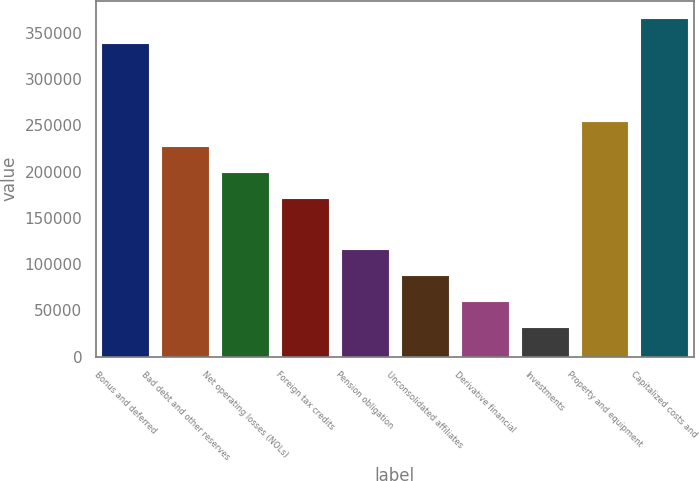<chart> <loc_0><loc_0><loc_500><loc_500><bar_chart><fcel>Bonus and deferred<fcel>Bad debt and other reserves<fcel>Net operating losses (NOLs)<fcel>Foreign tax credits<fcel>Pension obligation<fcel>Unconsolidated affiliates<fcel>Derivative financial<fcel>Investments<fcel>Property and equipment<fcel>Capitalized costs and<nl><fcel>338872<fcel>227440<fcel>199581<fcel>171723<fcel>116007<fcel>88148.6<fcel>60290.4<fcel>32432.2<fcel>255298<fcel>366731<nl></chart> 